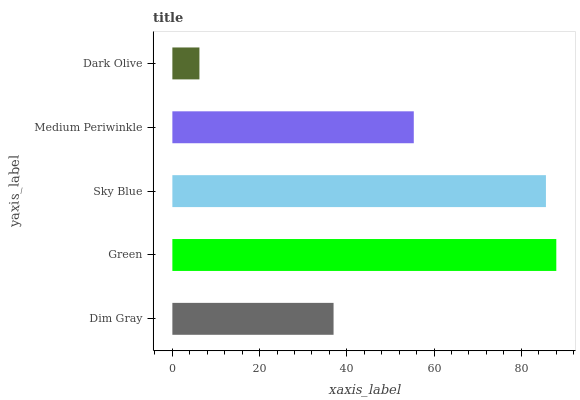Is Dark Olive the minimum?
Answer yes or no. Yes. Is Green the maximum?
Answer yes or no. Yes. Is Sky Blue the minimum?
Answer yes or no. No. Is Sky Blue the maximum?
Answer yes or no. No. Is Green greater than Sky Blue?
Answer yes or no. Yes. Is Sky Blue less than Green?
Answer yes or no. Yes. Is Sky Blue greater than Green?
Answer yes or no. No. Is Green less than Sky Blue?
Answer yes or no. No. Is Medium Periwinkle the high median?
Answer yes or no. Yes. Is Medium Periwinkle the low median?
Answer yes or no. Yes. Is Dim Gray the high median?
Answer yes or no. No. Is Green the low median?
Answer yes or no. No. 